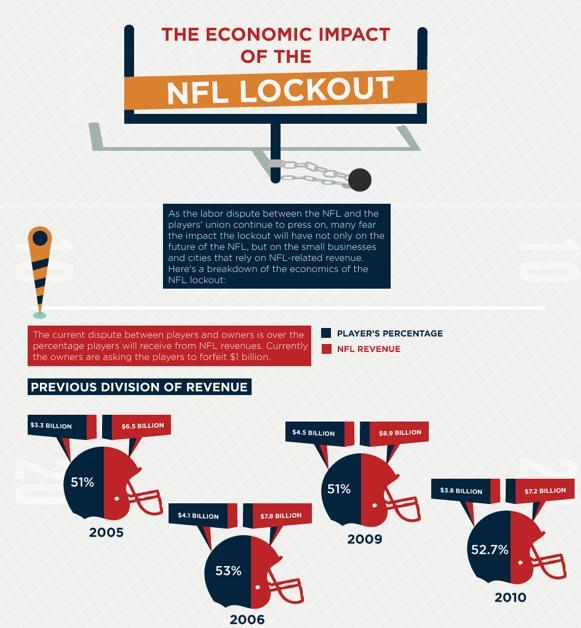What is the player's percentage from NFL revenues in 2009?
Answer the question with a short phrase. 51% What is the revenue generated by NFL in 2010? $7.2 BILLION What is the player's percentage from NFL revenues in 2006? 53% 